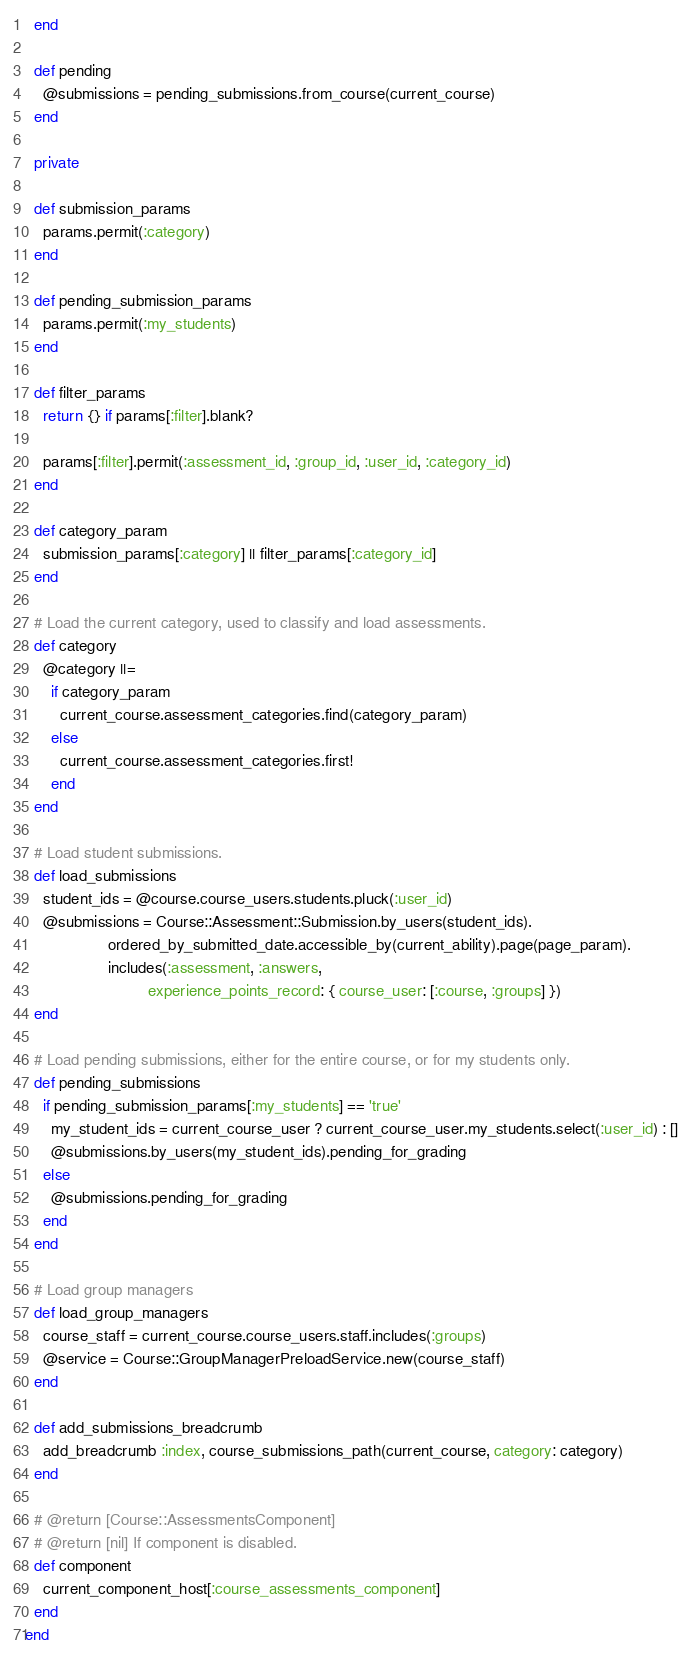<code> <loc_0><loc_0><loc_500><loc_500><_Ruby_>  end

  def pending
    @submissions = pending_submissions.from_course(current_course)
  end

  private

  def submission_params
    params.permit(:category)
  end

  def pending_submission_params
    params.permit(:my_students)
  end

  def filter_params
    return {} if params[:filter].blank?

    params[:filter].permit(:assessment_id, :group_id, :user_id, :category_id)
  end

  def category_param
    submission_params[:category] || filter_params[:category_id]
  end

  # Load the current category, used to classify and load assessments.
  def category
    @category ||=
      if category_param
        current_course.assessment_categories.find(category_param)
      else
        current_course.assessment_categories.first!
      end
  end

  # Load student submissions.
  def load_submissions
    student_ids = @course.course_users.students.pluck(:user_id)
    @submissions = Course::Assessment::Submission.by_users(student_ids).
                   ordered_by_submitted_date.accessible_by(current_ability).page(page_param).
                   includes(:assessment, :answers,
                            experience_points_record: { course_user: [:course, :groups] })
  end

  # Load pending submissions, either for the entire course, or for my students only.
  def pending_submissions
    if pending_submission_params[:my_students] == 'true'
      my_student_ids = current_course_user ? current_course_user.my_students.select(:user_id) : []
      @submissions.by_users(my_student_ids).pending_for_grading
    else
      @submissions.pending_for_grading
    end
  end

  # Load group managers
  def load_group_managers
    course_staff = current_course.course_users.staff.includes(:groups)
    @service = Course::GroupManagerPreloadService.new(course_staff)
  end

  def add_submissions_breadcrumb
    add_breadcrumb :index, course_submissions_path(current_course, category: category)
  end

  # @return [Course::AssessmentsComponent]
  # @return [nil] If component is disabled.
  def component
    current_component_host[:course_assessments_component]
  end
end
</code> 